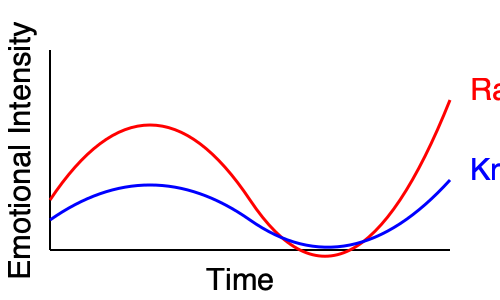In the romantic tale of Radha and Krishna, their emotional journey is depicted through curve plots. Analyze the graph and determine at which point in the story their emotions are most in sync, potentially indicating a moment of deepest connection or shared experience. To answer this question, we need to analyze the emotional journey of both Radha and Krishna as represented by the red and blue curves respectively. Let's break it down step-by-step:

1. Observe the overall pattern of both curves:
   - Radha's emotions (red curve) start high, dip in the middle, and end at a moderate level.
   - Krishna's emotions (blue curve) start moderately, rise slightly, then dip before ending at a moderate level.

2. Look for points where the curves are closest together or intersect:
   - At the beginning, the curves are far apart.
   - They come closer in the middle section.
   - Towards the end, they nearly converge.

3. Identify the point of closest proximity:
   - The curves are closest together near the end of the graph.
   - This point represents where Radha and Krishna's emotions are most similar in intensity.

4. Interpret this in the context of the story:
   - The convergence of emotions near the end suggests a moment of deep understanding or shared experience.
   - In many romantic tales, this could represent a reunion, reconciliation, or mutual realization of love.

5. Consider the cultural context:
   - In Indian romantic tales, especially those of Radha and Krishna, the journey often ends with a spiritual union or understanding.
   - The convergence of emotions at the end aligns with this cultural narrative.

Therefore, the point where their emotions are most in sync is towards the end of the story, indicating a moment of deepest connection or shared experience.
Answer: Towards the end of the story 